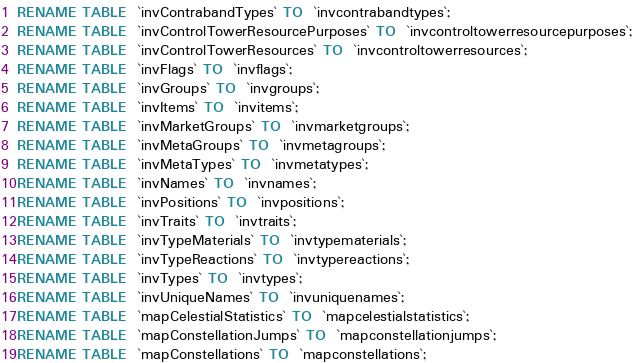<code> <loc_0><loc_0><loc_500><loc_500><_SQL_>RENAME TABLE  `invContrabandTypes` TO  `invcontrabandtypes`;
RENAME TABLE  `invControlTowerResourcePurposes` TO  `invcontroltowerresourcepurposes`;
RENAME TABLE  `invControlTowerResources` TO  `invcontroltowerresources`;
RENAME TABLE  `invFlags` TO  `invflags`;
RENAME TABLE  `invGroups` TO  `invgroups`;
RENAME TABLE  `invItems` TO  `invitems`;
RENAME TABLE  `invMarketGroups` TO  `invmarketgroups`;
RENAME TABLE  `invMetaGroups` TO  `invmetagroups`;
RENAME TABLE  `invMetaTypes` TO  `invmetatypes`;
RENAME TABLE  `invNames` TO  `invnames`;
RENAME TABLE  `invPositions` TO  `invpositions`;
RENAME TABLE  `invTraits` TO  `invtraits`;
RENAME TABLE  `invTypeMaterials` TO  `invtypematerials`;
RENAME TABLE  `invTypeReactions` TO  `invtypereactions`;
RENAME TABLE  `invTypes` TO  `invtypes`;
RENAME TABLE  `invUniqueNames` TO  `invuniquenames`;
RENAME TABLE  `mapCelestialStatistics` TO  `mapcelestialstatistics`;
RENAME TABLE  `mapConstellationJumps` TO  `mapconstellationjumps`;
RENAME TABLE  `mapConstellations` TO  `mapconstellations`;</code> 